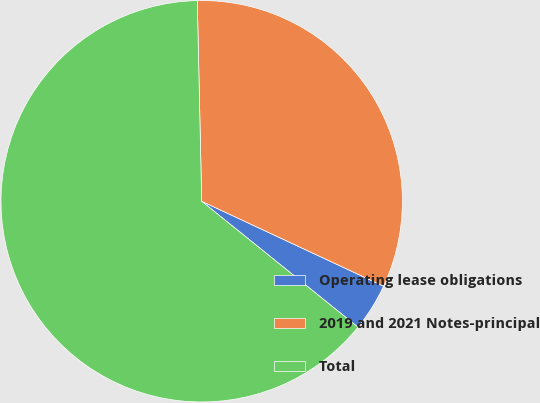Convert chart. <chart><loc_0><loc_0><loc_500><loc_500><pie_chart><fcel>Operating lease obligations<fcel>2019 and 2021 Notes-principal<fcel>Total<nl><fcel>3.84%<fcel>32.3%<fcel>63.85%<nl></chart> 